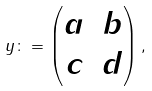Convert formula to latex. <formula><loc_0><loc_0><loc_500><loc_500>y \colon = \begin{pmatrix} a & b \\ c & d \end{pmatrix} ,</formula> 